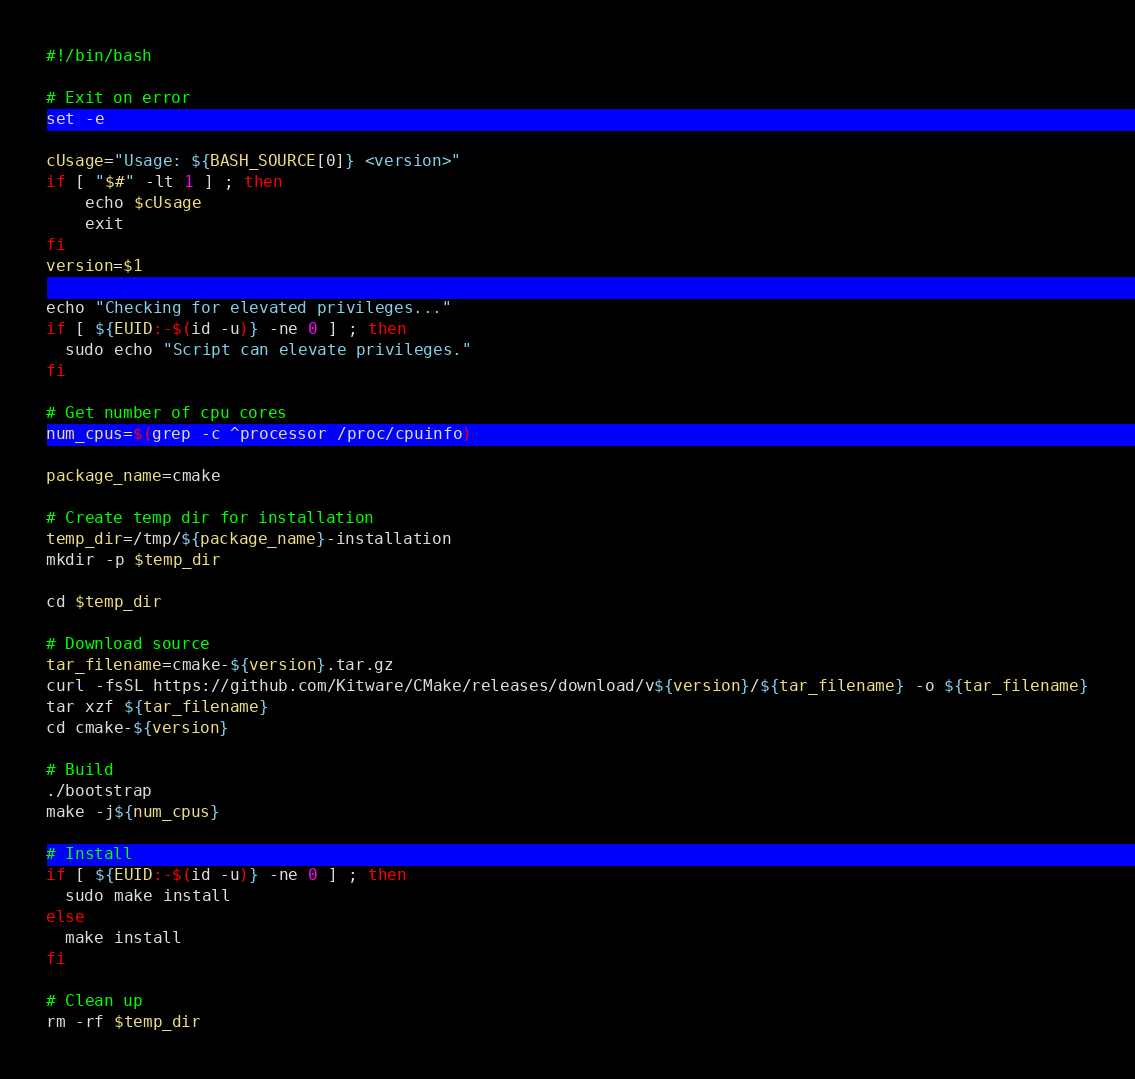<code> <loc_0><loc_0><loc_500><loc_500><_Bash_>#!/bin/bash

# Exit on error
set -e

cUsage="Usage: ${BASH_SOURCE[0]} <version>"
if [ "$#" -lt 1 ] ; then
    echo $cUsage
    exit
fi
version=$1

echo "Checking for elevated privileges..."
if [ ${EUID:-$(id -u)} -ne 0 ] ; then
  sudo echo "Script can elevate privileges."
fi

# Get number of cpu cores
num_cpus=$(grep -c ^processor /proc/cpuinfo)

package_name=cmake

# Create temp dir for installation
temp_dir=/tmp/${package_name}-installation
mkdir -p $temp_dir

cd $temp_dir

# Download source
tar_filename=cmake-${version}.tar.gz
curl -fsSL https://github.com/Kitware/CMake/releases/download/v${version}/${tar_filename} -o ${tar_filename}
tar xzf ${tar_filename}
cd cmake-${version}

# Build
./bootstrap
make -j${num_cpus}

# Install
if [ ${EUID:-$(id -u)} -ne 0 ] ; then
  sudo make install
else
  make install
fi

# Clean up
rm -rf $temp_dir
</code> 